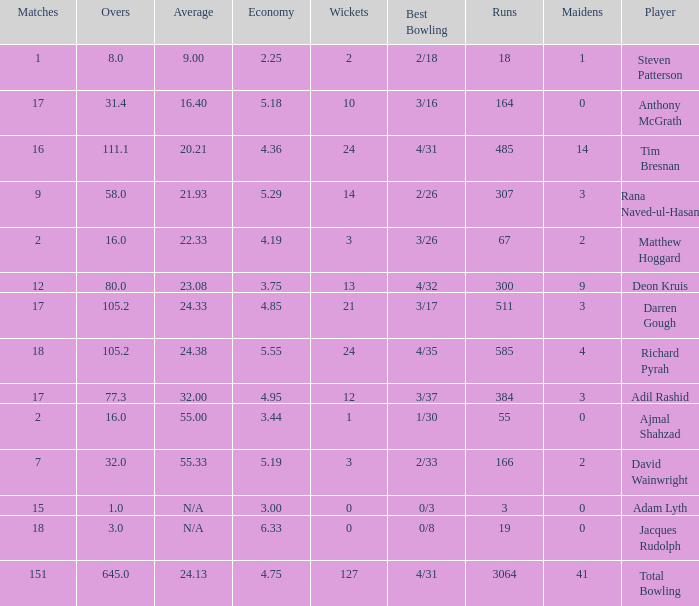What is the minimum number of overs required to achieve 18 runs? 8.0. 